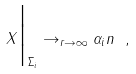Convert formula to latex. <formula><loc_0><loc_0><loc_500><loc_500>X \Big | _ { \Sigma _ { i } } \to _ { r \to \infty } \alpha _ { i } n \ ,</formula> 